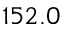Convert formula to latex. <formula><loc_0><loc_0><loc_500><loc_500>1 5 2 . 0</formula> 